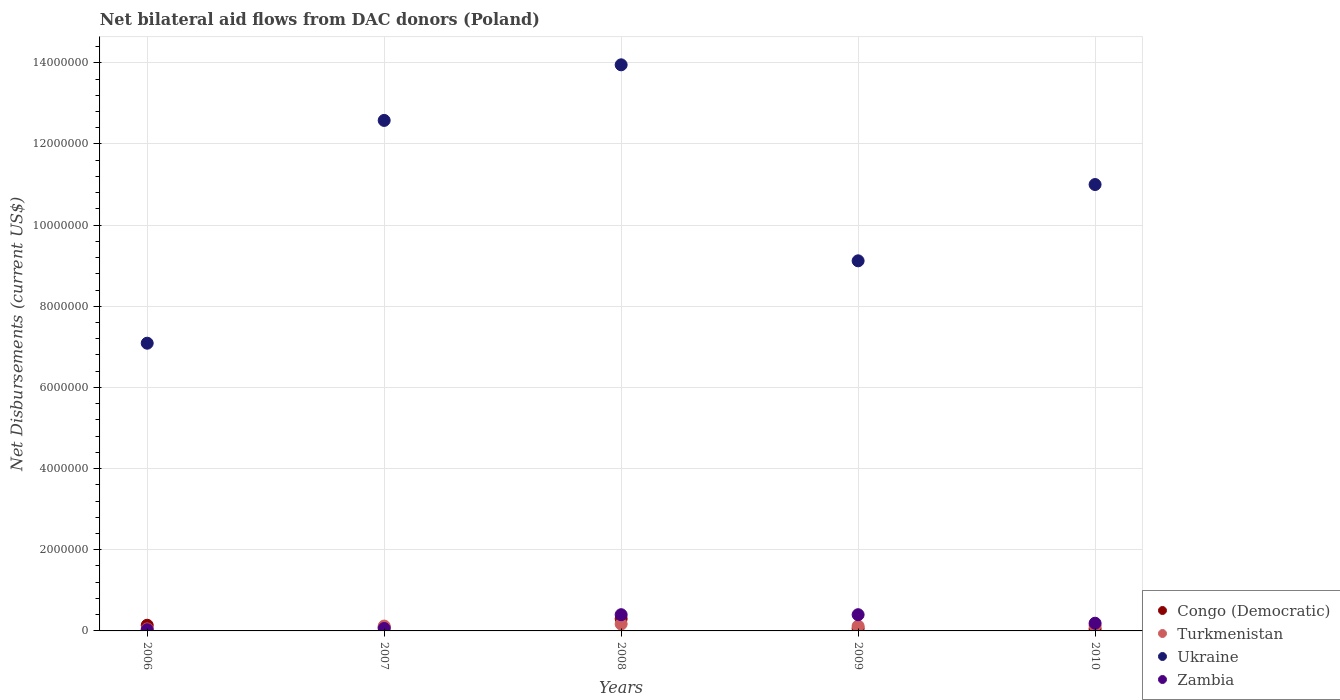What is the net bilateral aid flows in Congo (Democratic) in 2010?
Offer a terse response. 5.00e+04. Across all years, what is the maximum net bilateral aid flows in Zambia?
Ensure brevity in your answer.  4.00e+05. Across all years, what is the minimum net bilateral aid flows in Ukraine?
Your response must be concise. 7.09e+06. In which year was the net bilateral aid flows in Turkmenistan maximum?
Ensure brevity in your answer.  2008. What is the total net bilateral aid flows in Congo (Democratic) in the graph?
Provide a succinct answer. 6.40e+05. What is the difference between the net bilateral aid flows in Congo (Democratic) in 2006 and that in 2008?
Ensure brevity in your answer.  -1.60e+05. What is the difference between the net bilateral aid flows in Congo (Democratic) in 2006 and the net bilateral aid flows in Ukraine in 2008?
Provide a succinct answer. -1.38e+07. What is the average net bilateral aid flows in Zambia per year?
Offer a terse response. 2.16e+05. In the year 2010, what is the difference between the net bilateral aid flows in Congo (Democratic) and net bilateral aid flows in Turkmenistan?
Your answer should be compact. -8.00e+04. What is the ratio of the net bilateral aid flows in Zambia in 2006 to that in 2009?
Your answer should be compact. 0.07. Is the net bilateral aid flows in Ukraine in 2007 less than that in 2008?
Provide a short and direct response. Yes. Is the difference between the net bilateral aid flows in Congo (Democratic) in 2006 and 2009 greater than the difference between the net bilateral aid flows in Turkmenistan in 2006 and 2009?
Keep it short and to the point. Yes. What is the difference between the highest and the second highest net bilateral aid flows in Zambia?
Make the answer very short. 0. What is the difference between the highest and the lowest net bilateral aid flows in Congo (Democratic)?
Keep it short and to the point. 2.50e+05. Does the net bilateral aid flows in Congo (Democratic) monotonically increase over the years?
Offer a very short reply. No. How many dotlines are there?
Offer a terse response. 4. How many years are there in the graph?
Provide a short and direct response. 5. What is the difference between two consecutive major ticks on the Y-axis?
Your answer should be compact. 2.00e+06. Are the values on the major ticks of Y-axis written in scientific E-notation?
Your answer should be very brief. No. Does the graph contain any zero values?
Make the answer very short. No. How many legend labels are there?
Make the answer very short. 4. How are the legend labels stacked?
Make the answer very short. Vertical. What is the title of the graph?
Your answer should be very brief. Net bilateral aid flows from DAC donors (Poland). Does "Botswana" appear as one of the legend labels in the graph?
Give a very brief answer. No. What is the label or title of the X-axis?
Offer a very short reply. Years. What is the label or title of the Y-axis?
Ensure brevity in your answer.  Net Disbursements (current US$). What is the Net Disbursements (current US$) in Ukraine in 2006?
Your answer should be very brief. 7.09e+06. What is the Net Disbursements (current US$) of Congo (Democratic) in 2007?
Offer a very short reply. 9.00e+04. What is the Net Disbursements (current US$) in Ukraine in 2007?
Give a very brief answer. 1.26e+07. What is the Net Disbursements (current US$) in Zambia in 2007?
Give a very brief answer. 6.00e+04. What is the Net Disbursements (current US$) in Ukraine in 2008?
Ensure brevity in your answer.  1.40e+07. What is the Net Disbursements (current US$) of Zambia in 2008?
Give a very brief answer. 4.00e+05. What is the Net Disbursements (current US$) of Ukraine in 2009?
Your response must be concise. 9.12e+06. What is the Net Disbursements (current US$) of Zambia in 2009?
Keep it short and to the point. 4.00e+05. What is the Net Disbursements (current US$) of Turkmenistan in 2010?
Offer a very short reply. 1.30e+05. What is the Net Disbursements (current US$) of Ukraine in 2010?
Make the answer very short. 1.10e+07. Across all years, what is the maximum Net Disbursements (current US$) of Ukraine?
Provide a succinct answer. 1.40e+07. Across all years, what is the minimum Net Disbursements (current US$) of Ukraine?
Your answer should be compact. 7.09e+06. Across all years, what is the minimum Net Disbursements (current US$) of Zambia?
Provide a succinct answer. 3.00e+04. What is the total Net Disbursements (current US$) of Congo (Democratic) in the graph?
Keep it short and to the point. 6.40e+05. What is the total Net Disbursements (current US$) of Turkmenistan in the graph?
Make the answer very short. 5.90e+05. What is the total Net Disbursements (current US$) of Ukraine in the graph?
Your answer should be very brief. 5.37e+07. What is the total Net Disbursements (current US$) in Zambia in the graph?
Offer a terse response. 1.08e+06. What is the difference between the Net Disbursements (current US$) in Turkmenistan in 2006 and that in 2007?
Provide a succinct answer. -7.00e+04. What is the difference between the Net Disbursements (current US$) in Ukraine in 2006 and that in 2007?
Your answer should be compact. -5.49e+06. What is the difference between the Net Disbursements (current US$) in Zambia in 2006 and that in 2007?
Provide a succinct answer. -3.00e+04. What is the difference between the Net Disbursements (current US$) of Congo (Democratic) in 2006 and that in 2008?
Your response must be concise. -1.60e+05. What is the difference between the Net Disbursements (current US$) of Turkmenistan in 2006 and that in 2008?
Offer a terse response. -1.20e+05. What is the difference between the Net Disbursements (current US$) in Ukraine in 2006 and that in 2008?
Offer a very short reply. -6.86e+06. What is the difference between the Net Disbursements (current US$) in Zambia in 2006 and that in 2008?
Your answer should be compact. -3.70e+05. What is the difference between the Net Disbursements (current US$) in Congo (Democratic) in 2006 and that in 2009?
Give a very brief answer. 8.00e+04. What is the difference between the Net Disbursements (current US$) of Ukraine in 2006 and that in 2009?
Your answer should be very brief. -2.03e+06. What is the difference between the Net Disbursements (current US$) in Zambia in 2006 and that in 2009?
Keep it short and to the point. -3.70e+05. What is the difference between the Net Disbursements (current US$) in Ukraine in 2006 and that in 2010?
Make the answer very short. -3.91e+06. What is the difference between the Net Disbursements (current US$) in Zambia in 2006 and that in 2010?
Give a very brief answer. -1.60e+05. What is the difference between the Net Disbursements (current US$) in Congo (Democratic) in 2007 and that in 2008?
Provide a succinct answer. -2.10e+05. What is the difference between the Net Disbursements (current US$) of Turkmenistan in 2007 and that in 2008?
Provide a succinct answer. -5.00e+04. What is the difference between the Net Disbursements (current US$) of Ukraine in 2007 and that in 2008?
Offer a very short reply. -1.37e+06. What is the difference between the Net Disbursements (current US$) of Congo (Democratic) in 2007 and that in 2009?
Your response must be concise. 3.00e+04. What is the difference between the Net Disbursements (current US$) in Ukraine in 2007 and that in 2009?
Your answer should be compact. 3.46e+06. What is the difference between the Net Disbursements (current US$) of Congo (Democratic) in 2007 and that in 2010?
Offer a terse response. 4.00e+04. What is the difference between the Net Disbursements (current US$) in Turkmenistan in 2007 and that in 2010?
Your answer should be compact. -10000. What is the difference between the Net Disbursements (current US$) of Ukraine in 2007 and that in 2010?
Your response must be concise. 1.58e+06. What is the difference between the Net Disbursements (current US$) in Zambia in 2007 and that in 2010?
Offer a very short reply. -1.30e+05. What is the difference between the Net Disbursements (current US$) in Congo (Democratic) in 2008 and that in 2009?
Provide a succinct answer. 2.40e+05. What is the difference between the Net Disbursements (current US$) of Ukraine in 2008 and that in 2009?
Your answer should be compact. 4.83e+06. What is the difference between the Net Disbursements (current US$) of Congo (Democratic) in 2008 and that in 2010?
Offer a very short reply. 2.50e+05. What is the difference between the Net Disbursements (current US$) in Ukraine in 2008 and that in 2010?
Provide a short and direct response. 2.95e+06. What is the difference between the Net Disbursements (current US$) of Zambia in 2008 and that in 2010?
Give a very brief answer. 2.10e+05. What is the difference between the Net Disbursements (current US$) of Turkmenistan in 2009 and that in 2010?
Ensure brevity in your answer.  -10000. What is the difference between the Net Disbursements (current US$) in Ukraine in 2009 and that in 2010?
Give a very brief answer. -1.88e+06. What is the difference between the Net Disbursements (current US$) of Congo (Democratic) in 2006 and the Net Disbursements (current US$) of Ukraine in 2007?
Offer a very short reply. -1.24e+07. What is the difference between the Net Disbursements (current US$) in Congo (Democratic) in 2006 and the Net Disbursements (current US$) in Zambia in 2007?
Offer a very short reply. 8.00e+04. What is the difference between the Net Disbursements (current US$) of Turkmenistan in 2006 and the Net Disbursements (current US$) of Ukraine in 2007?
Your answer should be very brief. -1.25e+07. What is the difference between the Net Disbursements (current US$) of Ukraine in 2006 and the Net Disbursements (current US$) of Zambia in 2007?
Make the answer very short. 7.03e+06. What is the difference between the Net Disbursements (current US$) of Congo (Democratic) in 2006 and the Net Disbursements (current US$) of Turkmenistan in 2008?
Your answer should be compact. -3.00e+04. What is the difference between the Net Disbursements (current US$) of Congo (Democratic) in 2006 and the Net Disbursements (current US$) of Ukraine in 2008?
Your answer should be very brief. -1.38e+07. What is the difference between the Net Disbursements (current US$) of Congo (Democratic) in 2006 and the Net Disbursements (current US$) of Zambia in 2008?
Offer a very short reply. -2.60e+05. What is the difference between the Net Disbursements (current US$) in Turkmenistan in 2006 and the Net Disbursements (current US$) in Ukraine in 2008?
Your answer should be very brief. -1.39e+07. What is the difference between the Net Disbursements (current US$) of Turkmenistan in 2006 and the Net Disbursements (current US$) of Zambia in 2008?
Make the answer very short. -3.50e+05. What is the difference between the Net Disbursements (current US$) of Ukraine in 2006 and the Net Disbursements (current US$) of Zambia in 2008?
Provide a short and direct response. 6.69e+06. What is the difference between the Net Disbursements (current US$) of Congo (Democratic) in 2006 and the Net Disbursements (current US$) of Ukraine in 2009?
Your answer should be very brief. -8.98e+06. What is the difference between the Net Disbursements (current US$) in Turkmenistan in 2006 and the Net Disbursements (current US$) in Ukraine in 2009?
Your answer should be very brief. -9.07e+06. What is the difference between the Net Disbursements (current US$) in Turkmenistan in 2006 and the Net Disbursements (current US$) in Zambia in 2009?
Your response must be concise. -3.50e+05. What is the difference between the Net Disbursements (current US$) in Ukraine in 2006 and the Net Disbursements (current US$) in Zambia in 2009?
Ensure brevity in your answer.  6.69e+06. What is the difference between the Net Disbursements (current US$) of Congo (Democratic) in 2006 and the Net Disbursements (current US$) of Ukraine in 2010?
Your response must be concise. -1.09e+07. What is the difference between the Net Disbursements (current US$) of Congo (Democratic) in 2006 and the Net Disbursements (current US$) of Zambia in 2010?
Give a very brief answer. -5.00e+04. What is the difference between the Net Disbursements (current US$) of Turkmenistan in 2006 and the Net Disbursements (current US$) of Ukraine in 2010?
Give a very brief answer. -1.10e+07. What is the difference between the Net Disbursements (current US$) in Turkmenistan in 2006 and the Net Disbursements (current US$) in Zambia in 2010?
Offer a terse response. -1.40e+05. What is the difference between the Net Disbursements (current US$) in Ukraine in 2006 and the Net Disbursements (current US$) in Zambia in 2010?
Keep it short and to the point. 6.90e+06. What is the difference between the Net Disbursements (current US$) of Congo (Democratic) in 2007 and the Net Disbursements (current US$) of Ukraine in 2008?
Your answer should be very brief. -1.39e+07. What is the difference between the Net Disbursements (current US$) of Congo (Democratic) in 2007 and the Net Disbursements (current US$) of Zambia in 2008?
Provide a short and direct response. -3.10e+05. What is the difference between the Net Disbursements (current US$) in Turkmenistan in 2007 and the Net Disbursements (current US$) in Ukraine in 2008?
Your answer should be very brief. -1.38e+07. What is the difference between the Net Disbursements (current US$) in Turkmenistan in 2007 and the Net Disbursements (current US$) in Zambia in 2008?
Make the answer very short. -2.80e+05. What is the difference between the Net Disbursements (current US$) in Ukraine in 2007 and the Net Disbursements (current US$) in Zambia in 2008?
Offer a very short reply. 1.22e+07. What is the difference between the Net Disbursements (current US$) in Congo (Democratic) in 2007 and the Net Disbursements (current US$) in Ukraine in 2009?
Provide a short and direct response. -9.03e+06. What is the difference between the Net Disbursements (current US$) of Congo (Democratic) in 2007 and the Net Disbursements (current US$) of Zambia in 2009?
Offer a terse response. -3.10e+05. What is the difference between the Net Disbursements (current US$) in Turkmenistan in 2007 and the Net Disbursements (current US$) in Ukraine in 2009?
Provide a succinct answer. -9.00e+06. What is the difference between the Net Disbursements (current US$) in Turkmenistan in 2007 and the Net Disbursements (current US$) in Zambia in 2009?
Your answer should be very brief. -2.80e+05. What is the difference between the Net Disbursements (current US$) of Ukraine in 2007 and the Net Disbursements (current US$) of Zambia in 2009?
Keep it short and to the point. 1.22e+07. What is the difference between the Net Disbursements (current US$) of Congo (Democratic) in 2007 and the Net Disbursements (current US$) of Turkmenistan in 2010?
Your response must be concise. -4.00e+04. What is the difference between the Net Disbursements (current US$) in Congo (Democratic) in 2007 and the Net Disbursements (current US$) in Ukraine in 2010?
Give a very brief answer. -1.09e+07. What is the difference between the Net Disbursements (current US$) in Congo (Democratic) in 2007 and the Net Disbursements (current US$) in Zambia in 2010?
Make the answer very short. -1.00e+05. What is the difference between the Net Disbursements (current US$) of Turkmenistan in 2007 and the Net Disbursements (current US$) of Ukraine in 2010?
Your response must be concise. -1.09e+07. What is the difference between the Net Disbursements (current US$) of Ukraine in 2007 and the Net Disbursements (current US$) of Zambia in 2010?
Ensure brevity in your answer.  1.24e+07. What is the difference between the Net Disbursements (current US$) of Congo (Democratic) in 2008 and the Net Disbursements (current US$) of Ukraine in 2009?
Your answer should be very brief. -8.82e+06. What is the difference between the Net Disbursements (current US$) of Congo (Democratic) in 2008 and the Net Disbursements (current US$) of Zambia in 2009?
Your response must be concise. -1.00e+05. What is the difference between the Net Disbursements (current US$) in Turkmenistan in 2008 and the Net Disbursements (current US$) in Ukraine in 2009?
Offer a terse response. -8.95e+06. What is the difference between the Net Disbursements (current US$) in Ukraine in 2008 and the Net Disbursements (current US$) in Zambia in 2009?
Your answer should be very brief. 1.36e+07. What is the difference between the Net Disbursements (current US$) of Congo (Democratic) in 2008 and the Net Disbursements (current US$) of Ukraine in 2010?
Offer a very short reply. -1.07e+07. What is the difference between the Net Disbursements (current US$) in Congo (Democratic) in 2008 and the Net Disbursements (current US$) in Zambia in 2010?
Give a very brief answer. 1.10e+05. What is the difference between the Net Disbursements (current US$) in Turkmenistan in 2008 and the Net Disbursements (current US$) in Ukraine in 2010?
Your answer should be compact. -1.08e+07. What is the difference between the Net Disbursements (current US$) in Turkmenistan in 2008 and the Net Disbursements (current US$) in Zambia in 2010?
Keep it short and to the point. -2.00e+04. What is the difference between the Net Disbursements (current US$) of Ukraine in 2008 and the Net Disbursements (current US$) of Zambia in 2010?
Keep it short and to the point. 1.38e+07. What is the difference between the Net Disbursements (current US$) in Congo (Democratic) in 2009 and the Net Disbursements (current US$) in Ukraine in 2010?
Your response must be concise. -1.09e+07. What is the difference between the Net Disbursements (current US$) of Congo (Democratic) in 2009 and the Net Disbursements (current US$) of Zambia in 2010?
Offer a terse response. -1.30e+05. What is the difference between the Net Disbursements (current US$) of Turkmenistan in 2009 and the Net Disbursements (current US$) of Ukraine in 2010?
Provide a succinct answer. -1.09e+07. What is the difference between the Net Disbursements (current US$) in Turkmenistan in 2009 and the Net Disbursements (current US$) in Zambia in 2010?
Your response must be concise. -7.00e+04. What is the difference between the Net Disbursements (current US$) in Ukraine in 2009 and the Net Disbursements (current US$) in Zambia in 2010?
Provide a short and direct response. 8.93e+06. What is the average Net Disbursements (current US$) of Congo (Democratic) per year?
Keep it short and to the point. 1.28e+05. What is the average Net Disbursements (current US$) of Turkmenistan per year?
Offer a terse response. 1.18e+05. What is the average Net Disbursements (current US$) in Ukraine per year?
Your answer should be compact. 1.07e+07. What is the average Net Disbursements (current US$) of Zambia per year?
Ensure brevity in your answer.  2.16e+05. In the year 2006, what is the difference between the Net Disbursements (current US$) of Congo (Democratic) and Net Disbursements (current US$) of Turkmenistan?
Provide a succinct answer. 9.00e+04. In the year 2006, what is the difference between the Net Disbursements (current US$) of Congo (Democratic) and Net Disbursements (current US$) of Ukraine?
Give a very brief answer. -6.95e+06. In the year 2006, what is the difference between the Net Disbursements (current US$) of Congo (Democratic) and Net Disbursements (current US$) of Zambia?
Provide a succinct answer. 1.10e+05. In the year 2006, what is the difference between the Net Disbursements (current US$) in Turkmenistan and Net Disbursements (current US$) in Ukraine?
Your answer should be very brief. -7.04e+06. In the year 2006, what is the difference between the Net Disbursements (current US$) in Turkmenistan and Net Disbursements (current US$) in Zambia?
Make the answer very short. 2.00e+04. In the year 2006, what is the difference between the Net Disbursements (current US$) in Ukraine and Net Disbursements (current US$) in Zambia?
Your answer should be compact. 7.06e+06. In the year 2007, what is the difference between the Net Disbursements (current US$) of Congo (Democratic) and Net Disbursements (current US$) of Turkmenistan?
Provide a short and direct response. -3.00e+04. In the year 2007, what is the difference between the Net Disbursements (current US$) of Congo (Democratic) and Net Disbursements (current US$) of Ukraine?
Your response must be concise. -1.25e+07. In the year 2007, what is the difference between the Net Disbursements (current US$) in Congo (Democratic) and Net Disbursements (current US$) in Zambia?
Ensure brevity in your answer.  3.00e+04. In the year 2007, what is the difference between the Net Disbursements (current US$) of Turkmenistan and Net Disbursements (current US$) of Ukraine?
Give a very brief answer. -1.25e+07. In the year 2007, what is the difference between the Net Disbursements (current US$) in Turkmenistan and Net Disbursements (current US$) in Zambia?
Offer a terse response. 6.00e+04. In the year 2007, what is the difference between the Net Disbursements (current US$) in Ukraine and Net Disbursements (current US$) in Zambia?
Offer a very short reply. 1.25e+07. In the year 2008, what is the difference between the Net Disbursements (current US$) of Congo (Democratic) and Net Disbursements (current US$) of Ukraine?
Your answer should be compact. -1.36e+07. In the year 2008, what is the difference between the Net Disbursements (current US$) in Congo (Democratic) and Net Disbursements (current US$) in Zambia?
Give a very brief answer. -1.00e+05. In the year 2008, what is the difference between the Net Disbursements (current US$) in Turkmenistan and Net Disbursements (current US$) in Ukraine?
Provide a short and direct response. -1.38e+07. In the year 2008, what is the difference between the Net Disbursements (current US$) in Turkmenistan and Net Disbursements (current US$) in Zambia?
Give a very brief answer. -2.30e+05. In the year 2008, what is the difference between the Net Disbursements (current US$) of Ukraine and Net Disbursements (current US$) of Zambia?
Offer a very short reply. 1.36e+07. In the year 2009, what is the difference between the Net Disbursements (current US$) of Congo (Democratic) and Net Disbursements (current US$) of Turkmenistan?
Make the answer very short. -6.00e+04. In the year 2009, what is the difference between the Net Disbursements (current US$) of Congo (Democratic) and Net Disbursements (current US$) of Ukraine?
Provide a succinct answer. -9.06e+06. In the year 2009, what is the difference between the Net Disbursements (current US$) of Congo (Democratic) and Net Disbursements (current US$) of Zambia?
Make the answer very short. -3.40e+05. In the year 2009, what is the difference between the Net Disbursements (current US$) of Turkmenistan and Net Disbursements (current US$) of Ukraine?
Make the answer very short. -9.00e+06. In the year 2009, what is the difference between the Net Disbursements (current US$) of Turkmenistan and Net Disbursements (current US$) of Zambia?
Provide a succinct answer. -2.80e+05. In the year 2009, what is the difference between the Net Disbursements (current US$) in Ukraine and Net Disbursements (current US$) in Zambia?
Give a very brief answer. 8.72e+06. In the year 2010, what is the difference between the Net Disbursements (current US$) in Congo (Democratic) and Net Disbursements (current US$) in Turkmenistan?
Keep it short and to the point. -8.00e+04. In the year 2010, what is the difference between the Net Disbursements (current US$) of Congo (Democratic) and Net Disbursements (current US$) of Ukraine?
Provide a short and direct response. -1.10e+07. In the year 2010, what is the difference between the Net Disbursements (current US$) in Turkmenistan and Net Disbursements (current US$) in Ukraine?
Make the answer very short. -1.09e+07. In the year 2010, what is the difference between the Net Disbursements (current US$) of Ukraine and Net Disbursements (current US$) of Zambia?
Your answer should be very brief. 1.08e+07. What is the ratio of the Net Disbursements (current US$) in Congo (Democratic) in 2006 to that in 2007?
Offer a very short reply. 1.56. What is the ratio of the Net Disbursements (current US$) of Turkmenistan in 2006 to that in 2007?
Offer a terse response. 0.42. What is the ratio of the Net Disbursements (current US$) of Ukraine in 2006 to that in 2007?
Keep it short and to the point. 0.56. What is the ratio of the Net Disbursements (current US$) in Zambia in 2006 to that in 2007?
Ensure brevity in your answer.  0.5. What is the ratio of the Net Disbursements (current US$) of Congo (Democratic) in 2006 to that in 2008?
Keep it short and to the point. 0.47. What is the ratio of the Net Disbursements (current US$) of Turkmenistan in 2006 to that in 2008?
Your answer should be very brief. 0.29. What is the ratio of the Net Disbursements (current US$) of Ukraine in 2006 to that in 2008?
Provide a succinct answer. 0.51. What is the ratio of the Net Disbursements (current US$) in Zambia in 2006 to that in 2008?
Provide a short and direct response. 0.07. What is the ratio of the Net Disbursements (current US$) in Congo (Democratic) in 2006 to that in 2009?
Your answer should be very brief. 2.33. What is the ratio of the Net Disbursements (current US$) of Turkmenistan in 2006 to that in 2009?
Keep it short and to the point. 0.42. What is the ratio of the Net Disbursements (current US$) of Ukraine in 2006 to that in 2009?
Offer a terse response. 0.78. What is the ratio of the Net Disbursements (current US$) of Zambia in 2006 to that in 2009?
Offer a very short reply. 0.07. What is the ratio of the Net Disbursements (current US$) of Turkmenistan in 2006 to that in 2010?
Make the answer very short. 0.38. What is the ratio of the Net Disbursements (current US$) of Ukraine in 2006 to that in 2010?
Ensure brevity in your answer.  0.64. What is the ratio of the Net Disbursements (current US$) of Zambia in 2006 to that in 2010?
Give a very brief answer. 0.16. What is the ratio of the Net Disbursements (current US$) of Congo (Democratic) in 2007 to that in 2008?
Give a very brief answer. 0.3. What is the ratio of the Net Disbursements (current US$) in Turkmenistan in 2007 to that in 2008?
Your answer should be compact. 0.71. What is the ratio of the Net Disbursements (current US$) of Ukraine in 2007 to that in 2008?
Offer a terse response. 0.9. What is the ratio of the Net Disbursements (current US$) of Zambia in 2007 to that in 2008?
Make the answer very short. 0.15. What is the ratio of the Net Disbursements (current US$) of Congo (Democratic) in 2007 to that in 2009?
Provide a succinct answer. 1.5. What is the ratio of the Net Disbursements (current US$) of Turkmenistan in 2007 to that in 2009?
Keep it short and to the point. 1. What is the ratio of the Net Disbursements (current US$) in Ukraine in 2007 to that in 2009?
Provide a short and direct response. 1.38. What is the ratio of the Net Disbursements (current US$) in Zambia in 2007 to that in 2009?
Keep it short and to the point. 0.15. What is the ratio of the Net Disbursements (current US$) of Turkmenistan in 2007 to that in 2010?
Your answer should be compact. 0.92. What is the ratio of the Net Disbursements (current US$) in Ukraine in 2007 to that in 2010?
Provide a succinct answer. 1.14. What is the ratio of the Net Disbursements (current US$) in Zambia in 2007 to that in 2010?
Offer a terse response. 0.32. What is the ratio of the Net Disbursements (current US$) of Turkmenistan in 2008 to that in 2009?
Your answer should be very brief. 1.42. What is the ratio of the Net Disbursements (current US$) of Ukraine in 2008 to that in 2009?
Offer a terse response. 1.53. What is the ratio of the Net Disbursements (current US$) of Congo (Democratic) in 2008 to that in 2010?
Give a very brief answer. 6. What is the ratio of the Net Disbursements (current US$) of Turkmenistan in 2008 to that in 2010?
Ensure brevity in your answer.  1.31. What is the ratio of the Net Disbursements (current US$) in Ukraine in 2008 to that in 2010?
Offer a very short reply. 1.27. What is the ratio of the Net Disbursements (current US$) of Zambia in 2008 to that in 2010?
Provide a succinct answer. 2.11. What is the ratio of the Net Disbursements (current US$) of Turkmenistan in 2009 to that in 2010?
Provide a short and direct response. 0.92. What is the ratio of the Net Disbursements (current US$) of Ukraine in 2009 to that in 2010?
Your answer should be very brief. 0.83. What is the ratio of the Net Disbursements (current US$) of Zambia in 2009 to that in 2010?
Ensure brevity in your answer.  2.11. What is the difference between the highest and the second highest Net Disbursements (current US$) in Congo (Democratic)?
Provide a short and direct response. 1.60e+05. What is the difference between the highest and the second highest Net Disbursements (current US$) in Ukraine?
Provide a short and direct response. 1.37e+06. What is the difference between the highest and the lowest Net Disbursements (current US$) of Congo (Democratic)?
Provide a succinct answer. 2.50e+05. What is the difference between the highest and the lowest Net Disbursements (current US$) in Ukraine?
Your answer should be very brief. 6.86e+06. 